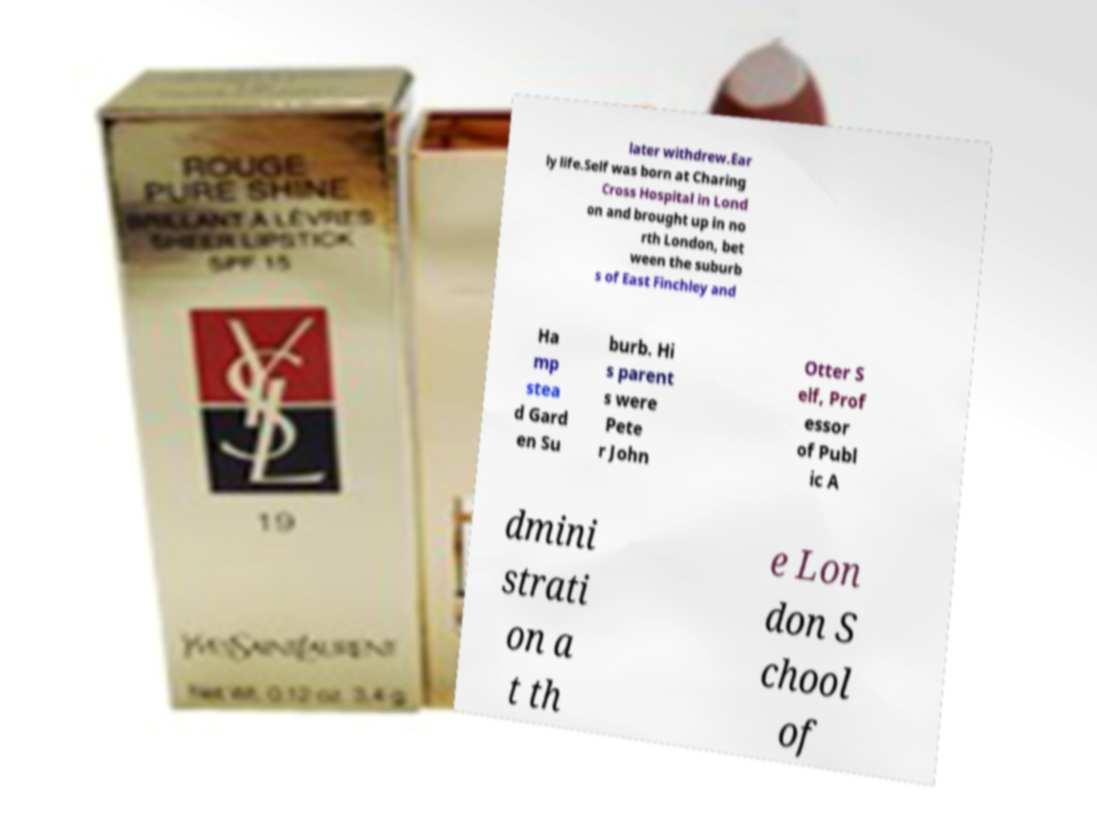Could you extract and type out the text from this image? later withdrew.Ear ly life.Self was born at Charing Cross Hospital in Lond on and brought up in no rth London, bet ween the suburb s of East Finchley and Ha mp stea d Gard en Su burb. Hi s parent s were Pete r John Otter S elf, Prof essor of Publ ic A dmini strati on a t th e Lon don S chool of 